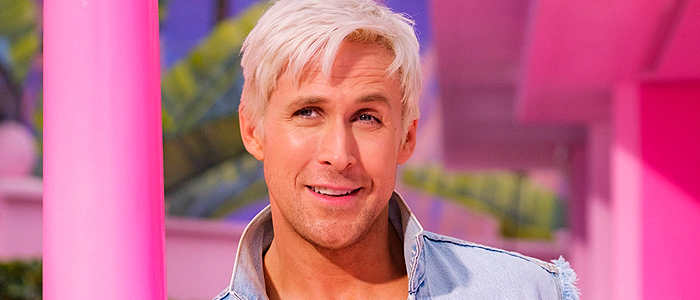Can you describe the fashion style visible in this image? The man’s fashion style in the image is casual with a touch of trendy chic, characterized by a ripped light blue denim jacket and a classic white t-shirt. The style is laid-back yet fashionable, typical of modern casual wear that's versatile for various informal settings. What does his expression and body language tell us about his mood? His direct gaze and slight smile, along with a relaxed stance leaning against a pole, suggest that he is comfortable and at ease. His open facial expression and accessible posture convey a friendly and confident demeanor, suggesting he is welcoming interaction. 